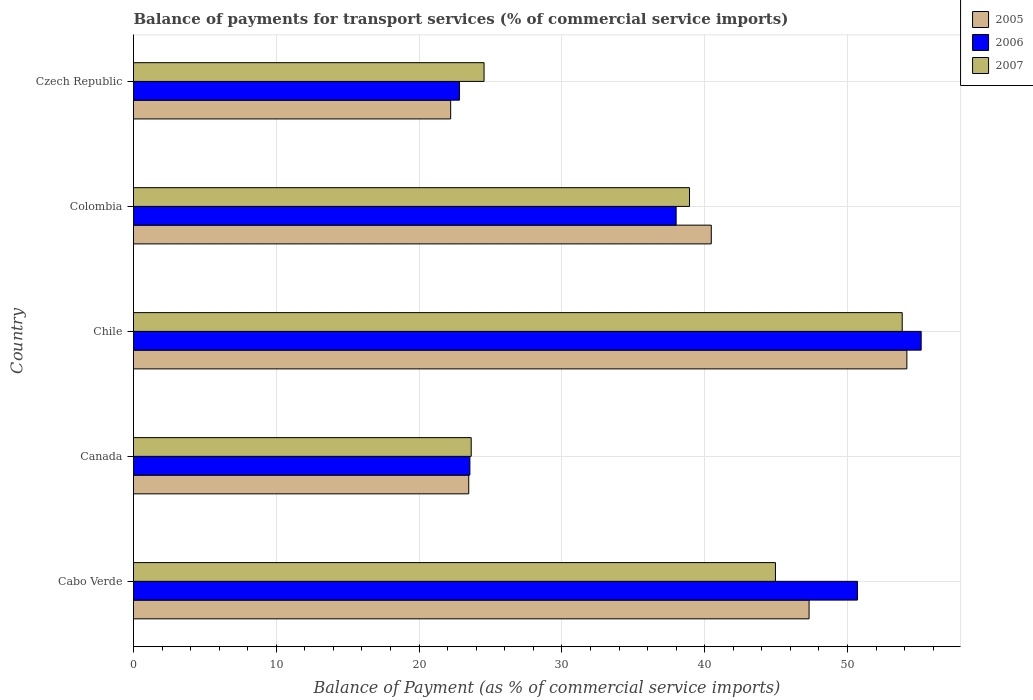How many different coloured bars are there?
Offer a terse response. 3. Are the number of bars per tick equal to the number of legend labels?
Offer a terse response. Yes. How many bars are there on the 1st tick from the bottom?
Offer a terse response. 3. In how many cases, is the number of bars for a given country not equal to the number of legend labels?
Your response must be concise. 0. What is the balance of payments for transport services in 2006 in Colombia?
Provide a short and direct response. 38. Across all countries, what is the maximum balance of payments for transport services in 2006?
Give a very brief answer. 55.16. Across all countries, what is the minimum balance of payments for transport services in 2006?
Your answer should be very brief. 22.82. In which country was the balance of payments for transport services in 2006 minimum?
Your response must be concise. Czech Republic. What is the total balance of payments for transport services in 2006 in the graph?
Provide a short and direct response. 190.24. What is the difference between the balance of payments for transport services in 2006 in Canada and that in Chile?
Provide a succinct answer. -31.6. What is the difference between the balance of payments for transport services in 2005 in Czech Republic and the balance of payments for transport services in 2007 in Chile?
Offer a terse response. -31.62. What is the average balance of payments for transport services in 2005 per country?
Give a very brief answer. 37.52. What is the difference between the balance of payments for transport services in 2006 and balance of payments for transport services in 2005 in Canada?
Ensure brevity in your answer.  0.08. In how many countries, is the balance of payments for transport services in 2005 greater than 10 %?
Make the answer very short. 5. What is the ratio of the balance of payments for transport services in 2005 in Cabo Verde to that in Czech Republic?
Your answer should be compact. 2.13. What is the difference between the highest and the second highest balance of payments for transport services in 2006?
Your response must be concise. 4.46. What is the difference between the highest and the lowest balance of payments for transport services in 2006?
Your response must be concise. 32.34. In how many countries, is the balance of payments for transport services in 2006 greater than the average balance of payments for transport services in 2006 taken over all countries?
Your response must be concise. 2. Is the sum of the balance of payments for transport services in 2006 in Cabo Verde and Colombia greater than the maximum balance of payments for transport services in 2007 across all countries?
Your answer should be compact. Yes. What does the 3rd bar from the top in Cabo Verde represents?
Offer a very short reply. 2005. What does the 1st bar from the bottom in Canada represents?
Provide a succinct answer. 2005. Is it the case that in every country, the sum of the balance of payments for transport services in 2007 and balance of payments for transport services in 2006 is greater than the balance of payments for transport services in 2005?
Offer a very short reply. Yes. Are all the bars in the graph horizontal?
Ensure brevity in your answer.  Yes. What is the difference between two consecutive major ticks on the X-axis?
Your answer should be very brief. 10. Are the values on the major ticks of X-axis written in scientific E-notation?
Your response must be concise. No. Does the graph contain grids?
Ensure brevity in your answer.  Yes. What is the title of the graph?
Offer a terse response. Balance of payments for transport services (% of commercial service imports). Does "1971" appear as one of the legend labels in the graph?
Offer a very short reply. No. What is the label or title of the X-axis?
Offer a very short reply. Balance of Payment (as % of commercial service imports). What is the label or title of the Y-axis?
Offer a terse response. Country. What is the Balance of Payment (as % of commercial service imports) in 2005 in Cabo Verde?
Make the answer very short. 47.31. What is the Balance of Payment (as % of commercial service imports) in 2006 in Cabo Verde?
Make the answer very short. 50.7. What is the Balance of Payment (as % of commercial service imports) in 2007 in Cabo Verde?
Your answer should be compact. 44.96. What is the Balance of Payment (as % of commercial service imports) in 2005 in Canada?
Offer a terse response. 23.48. What is the Balance of Payment (as % of commercial service imports) in 2006 in Canada?
Offer a terse response. 23.56. What is the Balance of Payment (as % of commercial service imports) of 2007 in Canada?
Provide a succinct answer. 23.65. What is the Balance of Payment (as % of commercial service imports) of 2005 in Chile?
Provide a succinct answer. 54.16. What is the Balance of Payment (as % of commercial service imports) in 2006 in Chile?
Your answer should be compact. 55.16. What is the Balance of Payment (as % of commercial service imports) in 2007 in Chile?
Ensure brevity in your answer.  53.83. What is the Balance of Payment (as % of commercial service imports) in 2005 in Colombia?
Offer a terse response. 40.46. What is the Balance of Payment (as % of commercial service imports) of 2006 in Colombia?
Your answer should be very brief. 38. What is the Balance of Payment (as % of commercial service imports) of 2007 in Colombia?
Offer a very short reply. 38.94. What is the Balance of Payment (as % of commercial service imports) in 2005 in Czech Republic?
Your response must be concise. 22.21. What is the Balance of Payment (as % of commercial service imports) in 2006 in Czech Republic?
Provide a short and direct response. 22.82. What is the Balance of Payment (as % of commercial service imports) in 2007 in Czech Republic?
Make the answer very short. 24.55. Across all countries, what is the maximum Balance of Payment (as % of commercial service imports) of 2005?
Ensure brevity in your answer.  54.16. Across all countries, what is the maximum Balance of Payment (as % of commercial service imports) of 2006?
Give a very brief answer. 55.16. Across all countries, what is the maximum Balance of Payment (as % of commercial service imports) in 2007?
Provide a succinct answer. 53.83. Across all countries, what is the minimum Balance of Payment (as % of commercial service imports) in 2005?
Ensure brevity in your answer.  22.21. Across all countries, what is the minimum Balance of Payment (as % of commercial service imports) of 2006?
Ensure brevity in your answer.  22.82. Across all countries, what is the minimum Balance of Payment (as % of commercial service imports) of 2007?
Ensure brevity in your answer.  23.65. What is the total Balance of Payment (as % of commercial service imports) of 2005 in the graph?
Give a very brief answer. 187.62. What is the total Balance of Payment (as % of commercial service imports) in 2006 in the graph?
Your answer should be very brief. 190.24. What is the total Balance of Payment (as % of commercial service imports) in 2007 in the graph?
Provide a succinct answer. 185.93. What is the difference between the Balance of Payment (as % of commercial service imports) in 2005 in Cabo Verde and that in Canada?
Keep it short and to the point. 23.84. What is the difference between the Balance of Payment (as % of commercial service imports) in 2006 in Cabo Verde and that in Canada?
Your answer should be compact. 27.14. What is the difference between the Balance of Payment (as % of commercial service imports) of 2007 in Cabo Verde and that in Canada?
Your response must be concise. 21.31. What is the difference between the Balance of Payment (as % of commercial service imports) in 2005 in Cabo Verde and that in Chile?
Your response must be concise. -6.85. What is the difference between the Balance of Payment (as % of commercial service imports) in 2006 in Cabo Verde and that in Chile?
Keep it short and to the point. -4.46. What is the difference between the Balance of Payment (as % of commercial service imports) of 2007 in Cabo Verde and that in Chile?
Give a very brief answer. -8.88. What is the difference between the Balance of Payment (as % of commercial service imports) in 2005 in Cabo Verde and that in Colombia?
Provide a succinct answer. 6.85. What is the difference between the Balance of Payment (as % of commercial service imports) in 2006 in Cabo Verde and that in Colombia?
Offer a terse response. 12.7. What is the difference between the Balance of Payment (as % of commercial service imports) in 2007 in Cabo Verde and that in Colombia?
Offer a very short reply. 6.02. What is the difference between the Balance of Payment (as % of commercial service imports) in 2005 in Cabo Verde and that in Czech Republic?
Your response must be concise. 25.1. What is the difference between the Balance of Payment (as % of commercial service imports) in 2006 in Cabo Verde and that in Czech Republic?
Your answer should be compact. 27.87. What is the difference between the Balance of Payment (as % of commercial service imports) in 2007 in Cabo Verde and that in Czech Republic?
Provide a short and direct response. 20.41. What is the difference between the Balance of Payment (as % of commercial service imports) in 2005 in Canada and that in Chile?
Provide a short and direct response. -30.68. What is the difference between the Balance of Payment (as % of commercial service imports) in 2006 in Canada and that in Chile?
Make the answer very short. -31.6. What is the difference between the Balance of Payment (as % of commercial service imports) of 2007 in Canada and that in Chile?
Make the answer very short. -30.19. What is the difference between the Balance of Payment (as % of commercial service imports) of 2005 in Canada and that in Colombia?
Make the answer very short. -16.99. What is the difference between the Balance of Payment (as % of commercial service imports) of 2006 in Canada and that in Colombia?
Make the answer very short. -14.44. What is the difference between the Balance of Payment (as % of commercial service imports) in 2007 in Canada and that in Colombia?
Offer a very short reply. -15.29. What is the difference between the Balance of Payment (as % of commercial service imports) of 2005 in Canada and that in Czech Republic?
Your answer should be very brief. 1.26. What is the difference between the Balance of Payment (as % of commercial service imports) in 2006 in Canada and that in Czech Republic?
Keep it short and to the point. 0.73. What is the difference between the Balance of Payment (as % of commercial service imports) in 2007 in Canada and that in Czech Republic?
Give a very brief answer. -0.9. What is the difference between the Balance of Payment (as % of commercial service imports) in 2005 in Chile and that in Colombia?
Offer a very short reply. 13.7. What is the difference between the Balance of Payment (as % of commercial service imports) in 2006 in Chile and that in Colombia?
Your response must be concise. 17.16. What is the difference between the Balance of Payment (as % of commercial service imports) in 2007 in Chile and that in Colombia?
Your answer should be very brief. 14.9. What is the difference between the Balance of Payment (as % of commercial service imports) in 2005 in Chile and that in Czech Republic?
Provide a succinct answer. 31.95. What is the difference between the Balance of Payment (as % of commercial service imports) of 2006 in Chile and that in Czech Republic?
Offer a terse response. 32.34. What is the difference between the Balance of Payment (as % of commercial service imports) in 2007 in Chile and that in Czech Republic?
Offer a terse response. 29.28. What is the difference between the Balance of Payment (as % of commercial service imports) in 2005 in Colombia and that in Czech Republic?
Keep it short and to the point. 18.25. What is the difference between the Balance of Payment (as % of commercial service imports) in 2006 in Colombia and that in Czech Republic?
Your response must be concise. 15.18. What is the difference between the Balance of Payment (as % of commercial service imports) of 2007 in Colombia and that in Czech Republic?
Your response must be concise. 14.39. What is the difference between the Balance of Payment (as % of commercial service imports) in 2005 in Cabo Verde and the Balance of Payment (as % of commercial service imports) in 2006 in Canada?
Your response must be concise. 23.75. What is the difference between the Balance of Payment (as % of commercial service imports) in 2005 in Cabo Verde and the Balance of Payment (as % of commercial service imports) in 2007 in Canada?
Ensure brevity in your answer.  23.66. What is the difference between the Balance of Payment (as % of commercial service imports) of 2006 in Cabo Verde and the Balance of Payment (as % of commercial service imports) of 2007 in Canada?
Offer a terse response. 27.05. What is the difference between the Balance of Payment (as % of commercial service imports) of 2005 in Cabo Verde and the Balance of Payment (as % of commercial service imports) of 2006 in Chile?
Ensure brevity in your answer.  -7.85. What is the difference between the Balance of Payment (as % of commercial service imports) in 2005 in Cabo Verde and the Balance of Payment (as % of commercial service imports) in 2007 in Chile?
Keep it short and to the point. -6.52. What is the difference between the Balance of Payment (as % of commercial service imports) in 2006 in Cabo Verde and the Balance of Payment (as % of commercial service imports) in 2007 in Chile?
Provide a succinct answer. -3.14. What is the difference between the Balance of Payment (as % of commercial service imports) of 2005 in Cabo Verde and the Balance of Payment (as % of commercial service imports) of 2006 in Colombia?
Provide a succinct answer. 9.31. What is the difference between the Balance of Payment (as % of commercial service imports) in 2005 in Cabo Verde and the Balance of Payment (as % of commercial service imports) in 2007 in Colombia?
Provide a succinct answer. 8.37. What is the difference between the Balance of Payment (as % of commercial service imports) in 2006 in Cabo Verde and the Balance of Payment (as % of commercial service imports) in 2007 in Colombia?
Your answer should be very brief. 11.76. What is the difference between the Balance of Payment (as % of commercial service imports) of 2005 in Cabo Verde and the Balance of Payment (as % of commercial service imports) of 2006 in Czech Republic?
Offer a terse response. 24.49. What is the difference between the Balance of Payment (as % of commercial service imports) of 2005 in Cabo Verde and the Balance of Payment (as % of commercial service imports) of 2007 in Czech Republic?
Your answer should be very brief. 22.76. What is the difference between the Balance of Payment (as % of commercial service imports) in 2006 in Cabo Verde and the Balance of Payment (as % of commercial service imports) in 2007 in Czech Republic?
Your answer should be very brief. 26.15. What is the difference between the Balance of Payment (as % of commercial service imports) in 2005 in Canada and the Balance of Payment (as % of commercial service imports) in 2006 in Chile?
Keep it short and to the point. -31.69. What is the difference between the Balance of Payment (as % of commercial service imports) of 2005 in Canada and the Balance of Payment (as % of commercial service imports) of 2007 in Chile?
Provide a succinct answer. -30.36. What is the difference between the Balance of Payment (as % of commercial service imports) of 2006 in Canada and the Balance of Payment (as % of commercial service imports) of 2007 in Chile?
Your answer should be compact. -30.28. What is the difference between the Balance of Payment (as % of commercial service imports) in 2005 in Canada and the Balance of Payment (as % of commercial service imports) in 2006 in Colombia?
Provide a short and direct response. -14.53. What is the difference between the Balance of Payment (as % of commercial service imports) in 2005 in Canada and the Balance of Payment (as % of commercial service imports) in 2007 in Colombia?
Keep it short and to the point. -15.46. What is the difference between the Balance of Payment (as % of commercial service imports) in 2006 in Canada and the Balance of Payment (as % of commercial service imports) in 2007 in Colombia?
Provide a succinct answer. -15.38. What is the difference between the Balance of Payment (as % of commercial service imports) in 2005 in Canada and the Balance of Payment (as % of commercial service imports) in 2006 in Czech Republic?
Offer a terse response. 0.65. What is the difference between the Balance of Payment (as % of commercial service imports) of 2005 in Canada and the Balance of Payment (as % of commercial service imports) of 2007 in Czech Republic?
Your response must be concise. -1.07. What is the difference between the Balance of Payment (as % of commercial service imports) of 2006 in Canada and the Balance of Payment (as % of commercial service imports) of 2007 in Czech Republic?
Provide a succinct answer. -0.99. What is the difference between the Balance of Payment (as % of commercial service imports) in 2005 in Chile and the Balance of Payment (as % of commercial service imports) in 2006 in Colombia?
Make the answer very short. 16.16. What is the difference between the Balance of Payment (as % of commercial service imports) of 2005 in Chile and the Balance of Payment (as % of commercial service imports) of 2007 in Colombia?
Offer a terse response. 15.22. What is the difference between the Balance of Payment (as % of commercial service imports) of 2006 in Chile and the Balance of Payment (as % of commercial service imports) of 2007 in Colombia?
Your answer should be very brief. 16.22. What is the difference between the Balance of Payment (as % of commercial service imports) of 2005 in Chile and the Balance of Payment (as % of commercial service imports) of 2006 in Czech Republic?
Make the answer very short. 31.34. What is the difference between the Balance of Payment (as % of commercial service imports) in 2005 in Chile and the Balance of Payment (as % of commercial service imports) in 2007 in Czech Republic?
Provide a short and direct response. 29.61. What is the difference between the Balance of Payment (as % of commercial service imports) in 2006 in Chile and the Balance of Payment (as % of commercial service imports) in 2007 in Czech Republic?
Provide a succinct answer. 30.61. What is the difference between the Balance of Payment (as % of commercial service imports) of 2005 in Colombia and the Balance of Payment (as % of commercial service imports) of 2006 in Czech Republic?
Offer a terse response. 17.64. What is the difference between the Balance of Payment (as % of commercial service imports) of 2005 in Colombia and the Balance of Payment (as % of commercial service imports) of 2007 in Czech Republic?
Ensure brevity in your answer.  15.91. What is the difference between the Balance of Payment (as % of commercial service imports) of 2006 in Colombia and the Balance of Payment (as % of commercial service imports) of 2007 in Czech Republic?
Give a very brief answer. 13.45. What is the average Balance of Payment (as % of commercial service imports) of 2005 per country?
Provide a short and direct response. 37.52. What is the average Balance of Payment (as % of commercial service imports) in 2006 per country?
Offer a very short reply. 38.05. What is the average Balance of Payment (as % of commercial service imports) in 2007 per country?
Keep it short and to the point. 37.19. What is the difference between the Balance of Payment (as % of commercial service imports) of 2005 and Balance of Payment (as % of commercial service imports) of 2006 in Cabo Verde?
Ensure brevity in your answer.  -3.39. What is the difference between the Balance of Payment (as % of commercial service imports) in 2005 and Balance of Payment (as % of commercial service imports) in 2007 in Cabo Verde?
Offer a terse response. 2.36. What is the difference between the Balance of Payment (as % of commercial service imports) of 2006 and Balance of Payment (as % of commercial service imports) of 2007 in Cabo Verde?
Give a very brief answer. 5.74. What is the difference between the Balance of Payment (as % of commercial service imports) in 2005 and Balance of Payment (as % of commercial service imports) in 2006 in Canada?
Give a very brief answer. -0.08. What is the difference between the Balance of Payment (as % of commercial service imports) in 2005 and Balance of Payment (as % of commercial service imports) in 2007 in Canada?
Offer a very short reply. -0.17. What is the difference between the Balance of Payment (as % of commercial service imports) in 2006 and Balance of Payment (as % of commercial service imports) in 2007 in Canada?
Offer a very short reply. -0.09. What is the difference between the Balance of Payment (as % of commercial service imports) of 2005 and Balance of Payment (as % of commercial service imports) of 2006 in Chile?
Your response must be concise. -1. What is the difference between the Balance of Payment (as % of commercial service imports) of 2005 and Balance of Payment (as % of commercial service imports) of 2007 in Chile?
Provide a succinct answer. 0.33. What is the difference between the Balance of Payment (as % of commercial service imports) in 2006 and Balance of Payment (as % of commercial service imports) in 2007 in Chile?
Offer a very short reply. 1.33. What is the difference between the Balance of Payment (as % of commercial service imports) of 2005 and Balance of Payment (as % of commercial service imports) of 2006 in Colombia?
Make the answer very short. 2.46. What is the difference between the Balance of Payment (as % of commercial service imports) in 2005 and Balance of Payment (as % of commercial service imports) in 2007 in Colombia?
Your response must be concise. 1.52. What is the difference between the Balance of Payment (as % of commercial service imports) of 2006 and Balance of Payment (as % of commercial service imports) of 2007 in Colombia?
Make the answer very short. -0.94. What is the difference between the Balance of Payment (as % of commercial service imports) in 2005 and Balance of Payment (as % of commercial service imports) in 2006 in Czech Republic?
Provide a short and direct response. -0.61. What is the difference between the Balance of Payment (as % of commercial service imports) in 2005 and Balance of Payment (as % of commercial service imports) in 2007 in Czech Republic?
Provide a short and direct response. -2.34. What is the difference between the Balance of Payment (as % of commercial service imports) in 2006 and Balance of Payment (as % of commercial service imports) in 2007 in Czech Republic?
Offer a very short reply. -1.72. What is the ratio of the Balance of Payment (as % of commercial service imports) in 2005 in Cabo Verde to that in Canada?
Ensure brevity in your answer.  2.02. What is the ratio of the Balance of Payment (as % of commercial service imports) in 2006 in Cabo Verde to that in Canada?
Your answer should be compact. 2.15. What is the ratio of the Balance of Payment (as % of commercial service imports) in 2007 in Cabo Verde to that in Canada?
Your response must be concise. 1.9. What is the ratio of the Balance of Payment (as % of commercial service imports) of 2005 in Cabo Verde to that in Chile?
Keep it short and to the point. 0.87. What is the ratio of the Balance of Payment (as % of commercial service imports) of 2006 in Cabo Verde to that in Chile?
Keep it short and to the point. 0.92. What is the ratio of the Balance of Payment (as % of commercial service imports) in 2007 in Cabo Verde to that in Chile?
Give a very brief answer. 0.84. What is the ratio of the Balance of Payment (as % of commercial service imports) in 2005 in Cabo Verde to that in Colombia?
Ensure brevity in your answer.  1.17. What is the ratio of the Balance of Payment (as % of commercial service imports) of 2006 in Cabo Verde to that in Colombia?
Provide a short and direct response. 1.33. What is the ratio of the Balance of Payment (as % of commercial service imports) in 2007 in Cabo Verde to that in Colombia?
Make the answer very short. 1.15. What is the ratio of the Balance of Payment (as % of commercial service imports) of 2005 in Cabo Verde to that in Czech Republic?
Your response must be concise. 2.13. What is the ratio of the Balance of Payment (as % of commercial service imports) of 2006 in Cabo Verde to that in Czech Republic?
Make the answer very short. 2.22. What is the ratio of the Balance of Payment (as % of commercial service imports) in 2007 in Cabo Verde to that in Czech Republic?
Keep it short and to the point. 1.83. What is the ratio of the Balance of Payment (as % of commercial service imports) in 2005 in Canada to that in Chile?
Give a very brief answer. 0.43. What is the ratio of the Balance of Payment (as % of commercial service imports) in 2006 in Canada to that in Chile?
Provide a succinct answer. 0.43. What is the ratio of the Balance of Payment (as % of commercial service imports) of 2007 in Canada to that in Chile?
Ensure brevity in your answer.  0.44. What is the ratio of the Balance of Payment (as % of commercial service imports) of 2005 in Canada to that in Colombia?
Your answer should be very brief. 0.58. What is the ratio of the Balance of Payment (as % of commercial service imports) of 2006 in Canada to that in Colombia?
Make the answer very short. 0.62. What is the ratio of the Balance of Payment (as % of commercial service imports) in 2007 in Canada to that in Colombia?
Your answer should be compact. 0.61. What is the ratio of the Balance of Payment (as % of commercial service imports) of 2005 in Canada to that in Czech Republic?
Give a very brief answer. 1.06. What is the ratio of the Balance of Payment (as % of commercial service imports) of 2006 in Canada to that in Czech Republic?
Offer a terse response. 1.03. What is the ratio of the Balance of Payment (as % of commercial service imports) in 2007 in Canada to that in Czech Republic?
Give a very brief answer. 0.96. What is the ratio of the Balance of Payment (as % of commercial service imports) of 2005 in Chile to that in Colombia?
Provide a short and direct response. 1.34. What is the ratio of the Balance of Payment (as % of commercial service imports) in 2006 in Chile to that in Colombia?
Make the answer very short. 1.45. What is the ratio of the Balance of Payment (as % of commercial service imports) in 2007 in Chile to that in Colombia?
Your answer should be compact. 1.38. What is the ratio of the Balance of Payment (as % of commercial service imports) of 2005 in Chile to that in Czech Republic?
Offer a terse response. 2.44. What is the ratio of the Balance of Payment (as % of commercial service imports) in 2006 in Chile to that in Czech Republic?
Provide a succinct answer. 2.42. What is the ratio of the Balance of Payment (as % of commercial service imports) of 2007 in Chile to that in Czech Republic?
Keep it short and to the point. 2.19. What is the ratio of the Balance of Payment (as % of commercial service imports) of 2005 in Colombia to that in Czech Republic?
Your response must be concise. 1.82. What is the ratio of the Balance of Payment (as % of commercial service imports) of 2006 in Colombia to that in Czech Republic?
Provide a succinct answer. 1.66. What is the ratio of the Balance of Payment (as % of commercial service imports) of 2007 in Colombia to that in Czech Republic?
Your response must be concise. 1.59. What is the difference between the highest and the second highest Balance of Payment (as % of commercial service imports) of 2005?
Ensure brevity in your answer.  6.85. What is the difference between the highest and the second highest Balance of Payment (as % of commercial service imports) in 2006?
Your answer should be compact. 4.46. What is the difference between the highest and the second highest Balance of Payment (as % of commercial service imports) of 2007?
Provide a succinct answer. 8.88. What is the difference between the highest and the lowest Balance of Payment (as % of commercial service imports) in 2005?
Offer a terse response. 31.95. What is the difference between the highest and the lowest Balance of Payment (as % of commercial service imports) of 2006?
Your response must be concise. 32.34. What is the difference between the highest and the lowest Balance of Payment (as % of commercial service imports) of 2007?
Offer a very short reply. 30.19. 